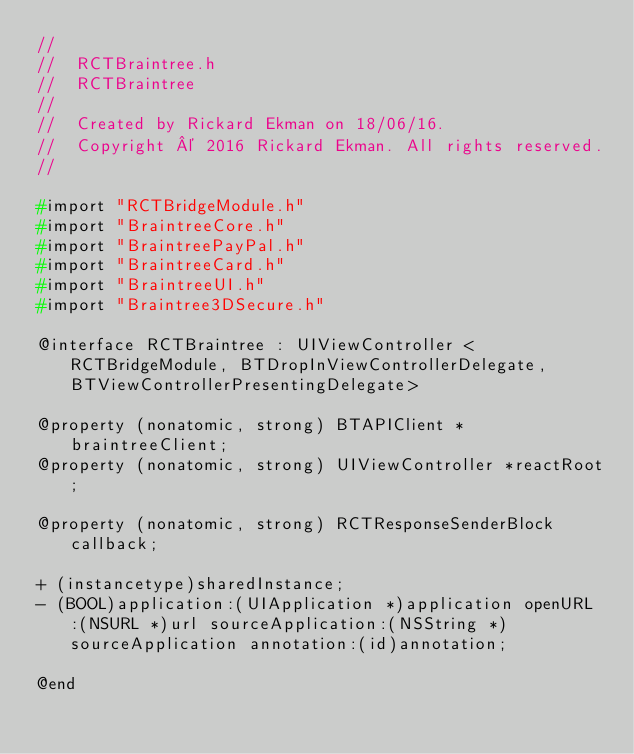<code> <loc_0><loc_0><loc_500><loc_500><_C_>//
//  RCTBraintree.h
//  RCTBraintree
//
//  Created by Rickard Ekman on 18/06/16.
//  Copyright © 2016 Rickard Ekman. All rights reserved.
//

#import "RCTBridgeModule.h"
#import "BraintreeCore.h"
#import "BraintreePayPal.h"
#import "BraintreeCard.h"
#import "BraintreeUI.h"
#import "Braintree3DSecure.h"

@interface RCTBraintree : UIViewController <RCTBridgeModule, BTDropInViewControllerDelegate, BTViewControllerPresentingDelegate>

@property (nonatomic, strong) BTAPIClient *braintreeClient;
@property (nonatomic, strong) UIViewController *reactRoot;

@property (nonatomic, strong) RCTResponseSenderBlock callback;

+ (instancetype)sharedInstance;
- (BOOL)application:(UIApplication *)application openURL:(NSURL *)url sourceApplication:(NSString *)sourceApplication annotation:(id)annotation;

@end
</code> 